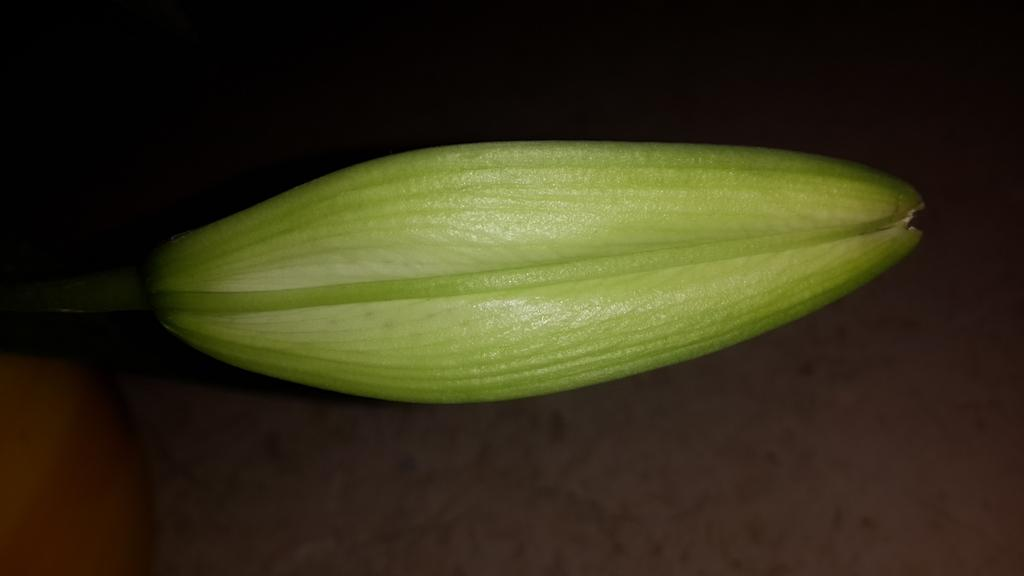What is the main subject of the image? The main subject of the image is a bud of a flower. Can you describe the stage of the flower in the image? The flower is in the bud stage, which means it has not yet bloomed. What might happen to the bud in the future? The bud may bloom into a full flower, depending on its species and environmental conditions. What role does the father play in the image? There is no father present in the image, as it only features a bud of a flower. Is there a volcano visible in the image? No, there is no volcano present in the image; it only features a bud of a flower. 